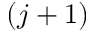<formula> <loc_0><loc_0><loc_500><loc_500>( j + 1 )</formula> 